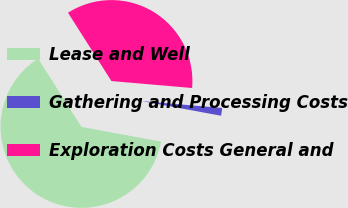Convert chart to OTSL. <chart><loc_0><loc_0><loc_500><loc_500><pie_chart><fcel>Lease and Well<fcel>Gathering and Processing Costs<fcel>Exploration Costs General and<nl><fcel>63.08%<fcel>1.54%<fcel>35.38%<nl></chart> 